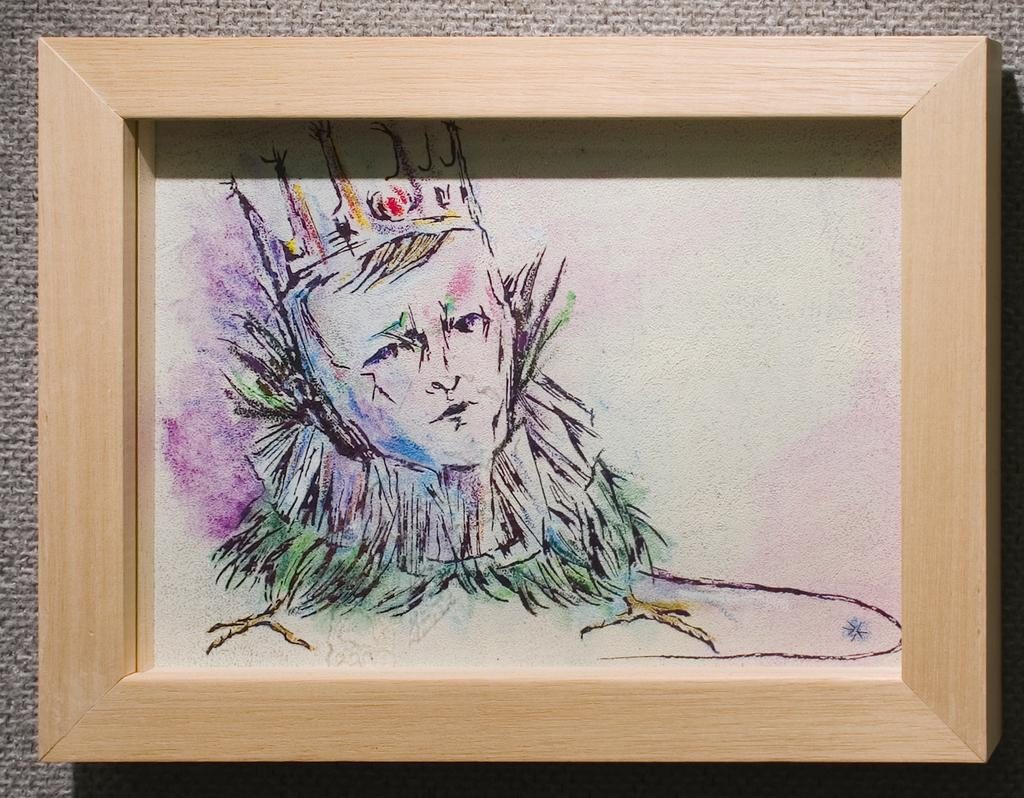What is the main subject of the image? There is a portrait in the center of the image. How many tomatoes are placed on the nose of the person in the portrait? There are no tomatoes present in the image, and the person's nose is not mentioned. 